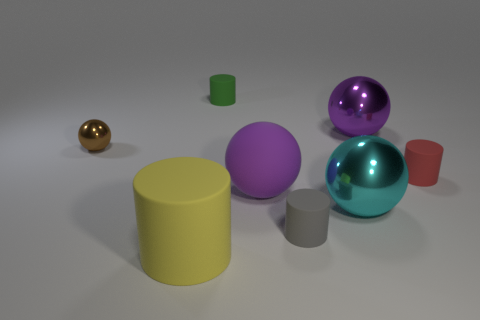What is the function of the collection of objects shown in this image? This collection of objects appears to be designed for a visual demonstration, possibly to illustrate different shapes, sizes, and materials in a 3D modeling or rendering context. 